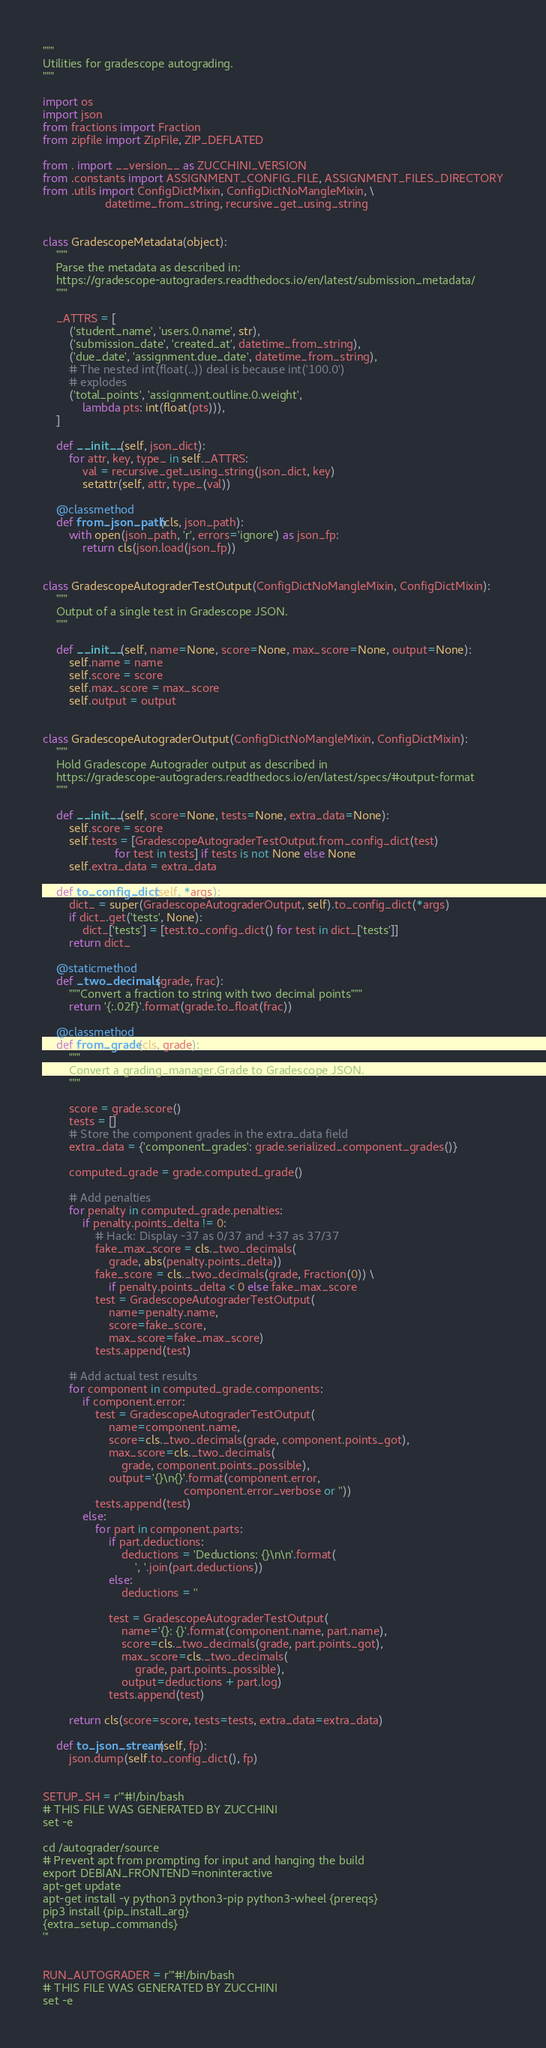Convert code to text. <code><loc_0><loc_0><loc_500><loc_500><_Python_>"""
Utilities for gradescope autograding.
"""

import os
import json
from fractions import Fraction
from zipfile import ZipFile, ZIP_DEFLATED

from . import __version__ as ZUCCHINI_VERSION
from .constants import ASSIGNMENT_CONFIG_FILE, ASSIGNMENT_FILES_DIRECTORY
from .utils import ConfigDictMixin, ConfigDictNoMangleMixin, \
                   datetime_from_string, recursive_get_using_string


class GradescopeMetadata(object):
    """
    Parse the metadata as described in:
    https://gradescope-autograders.readthedocs.io/en/latest/submission_metadata/
    """

    _ATTRS = [
        ('student_name', 'users.0.name', str),
        ('submission_date', 'created_at', datetime_from_string),
        ('due_date', 'assignment.due_date', datetime_from_string),
        # The nested int(float(..)) deal is because int('100.0')
        # explodes
        ('total_points', 'assignment.outline.0.weight',
            lambda pts: int(float(pts))),
    ]

    def __init__(self, json_dict):
        for attr, key, type_ in self._ATTRS:
            val = recursive_get_using_string(json_dict, key)
            setattr(self, attr, type_(val))

    @classmethod
    def from_json_path(cls, json_path):
        with open(json_path, 'r', errors='ignore') as json_fp:
            return cls(json.load(json_fp))


class GradescopeAutograderTestOutput(ConfigDictNoMangleMixin, ConfigDictMixin):
    """
    Output of a single test in Gradescope JSON.
    """

    def __init__(self, name=None, score=None, max_score=None, output=None):
        self.name = name
        self.score = score
        self.max_score = max_score
        self.output = output


class GradescopeAutograderOutput(ConfigDictNoMangleMixin, ConfigDictMixin):
    """
    Hold Gradescope Autograder output as described in
    https://gradescope-autograders.readthedocs.io/en/latest/specs/#output-format
    """

    def __init__(self, score=None, tests=None, extra_data=None):
        self.score = score
        self.tests = [GradescopeAutograderTestOutput.from_config_dict(test)
                      for test in tests] if tests is not None else None
        self.extra_data = extra_data

    def to_config_dict(self, *args):
        dict_ = super(GradescopeAutograderOutput, self).to_config_dict(*args)
        if dict_.get('tests', None):
            dict_['tests'] = [test.to_config_dict() for test in dict_['tests']]
        return dict_

    @staticmethod
    def _two_decimals(grade, frac):
        """Convert a fraction to string with two decimal points"""
        return '{:.02f}'.format(grade.to_float(frac))

    @classmethod
    def from_grade(cls, grade):
        """
        Convert a grading_manager.Grade to Gradescope JSON.
        """

        score = grade.score()
        tests = []
        # Store the component grades in the extra_data field
        extra_data = {'component_grades': grade.serialized_component_grades()}

        computed_grade = grade.computed_grade()

        # Add penalties
        for penalty in computed_grade.penalties:
            if penalty.points_delta != 0:
                # Hack: Display -37 as 0/37 and +37 as 37/37
                fake_max_score = cls._two_decimals(
                    grade, abs(penalty.points_delta))
                fake_score = cls._two_decimals(grade, Fraction(0)) \
                    if penalty.points_delta < 0 else fake_max_score
                test = GradescopeAutograderTestOutput(
                    name=penalty.name,
                    score=fake_score,
                    max_score=fake_max_score)
                tests.append(test)

        # Add actual test results
        for component in computed_grade.components:
            if component.error:
                test = GradescopeAutograderTestOutput(
                    name=component.name,
                    score=cls._two_decimals(grade, component.points_got),
                    max_score=cls._two_decimals(
                        grade, component.points_possible),
                    output='{}\n{}'.format(component.error,
                                           component.error_verbose or ''))
                tests.append(test)
            else:
                for part in component.parts:
                    if part.deductions:
                        deductions = 'Deductions: {}\n\n'.format(
                            ', '.join(part.deductions))
                    else:
                        deductions = ''

                    test = GradescopeAutograderTestOutput(
                        name='{}: {}'.format(component.name, part.name),
                        score=cls._two_decimals(grade, part.points_got),
                        max_score=cls._two_decimals(
                            grade, part.points_possible),
                        output=deductions + part.log)
                    tests.append(test)

        return cls(score=score, tests=tests, extra_data=extra_data)

    def to_json_stream(self, fp):
        json.dump(self.to_config_dict(), fp)


SETUP_SH = r'''#!/bin/bash
# THIS FILE WAS GENERATED BY ZUCCHINI
set -e

cd /autograder/source
# Prevent apt from prompting for input and hanging the build
export DEBIAN_FRONTEND=noninteractive
apt-get update
apt-get install -y python3 python3-pip python3-wheel {prereqs}
pip3 install {pip_install_arg}
{extra_setup_commands}
'''


RUN_AUTOGRADER = r'''#!/bin/bash
# THIS FILE WAS GENERATED BY ZUCCHINI
set -e</code> 